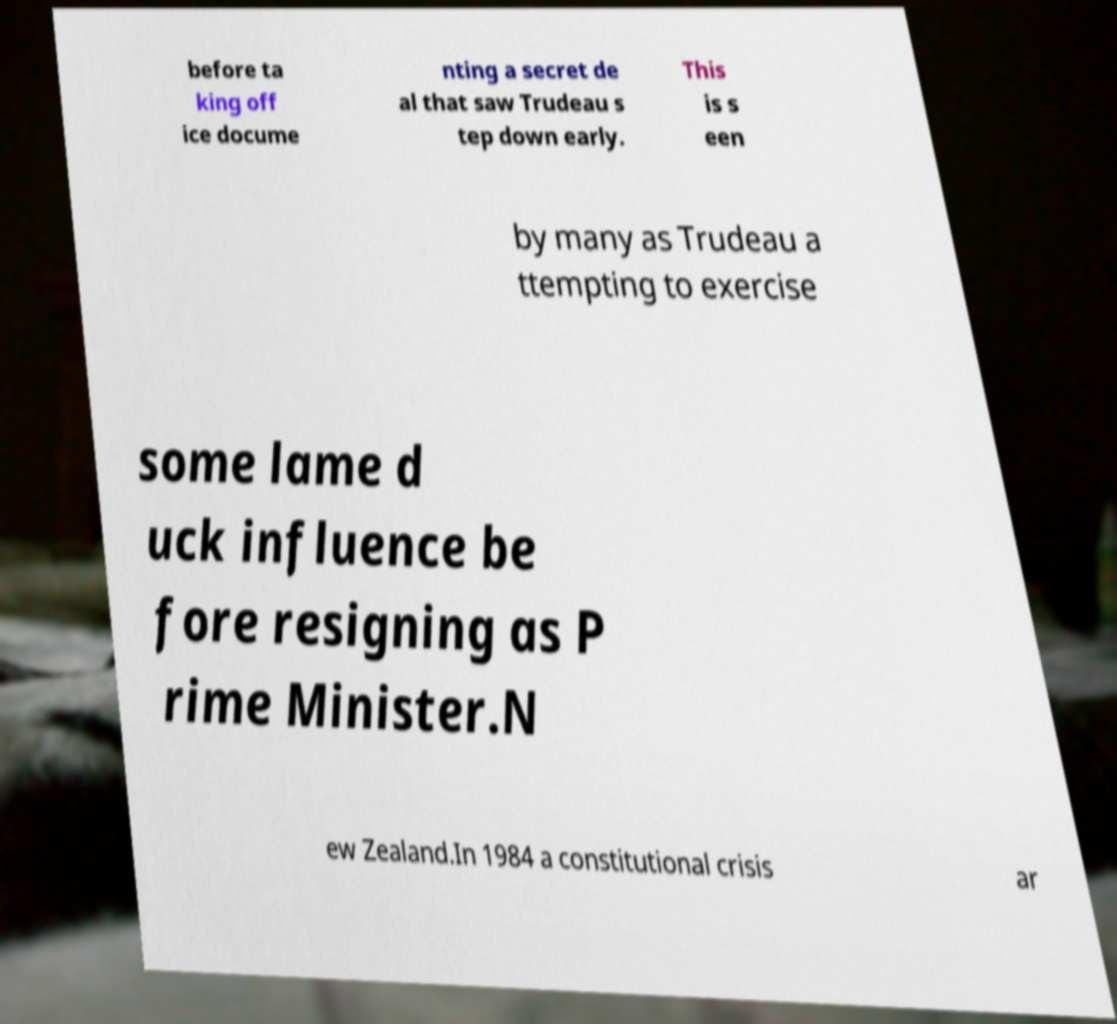There's text embedded in this image that I need extracted. Can you transcribe it verbatim? before ta king off ice docume nting a secret de al that saw Trudeau s tep down early. This is s een by many as Trudeau a ttempting to exercise some lame d uck influence be fore resigning as P rime Minister.N ew Zealand.In 1984 a constitutional crisis ar 